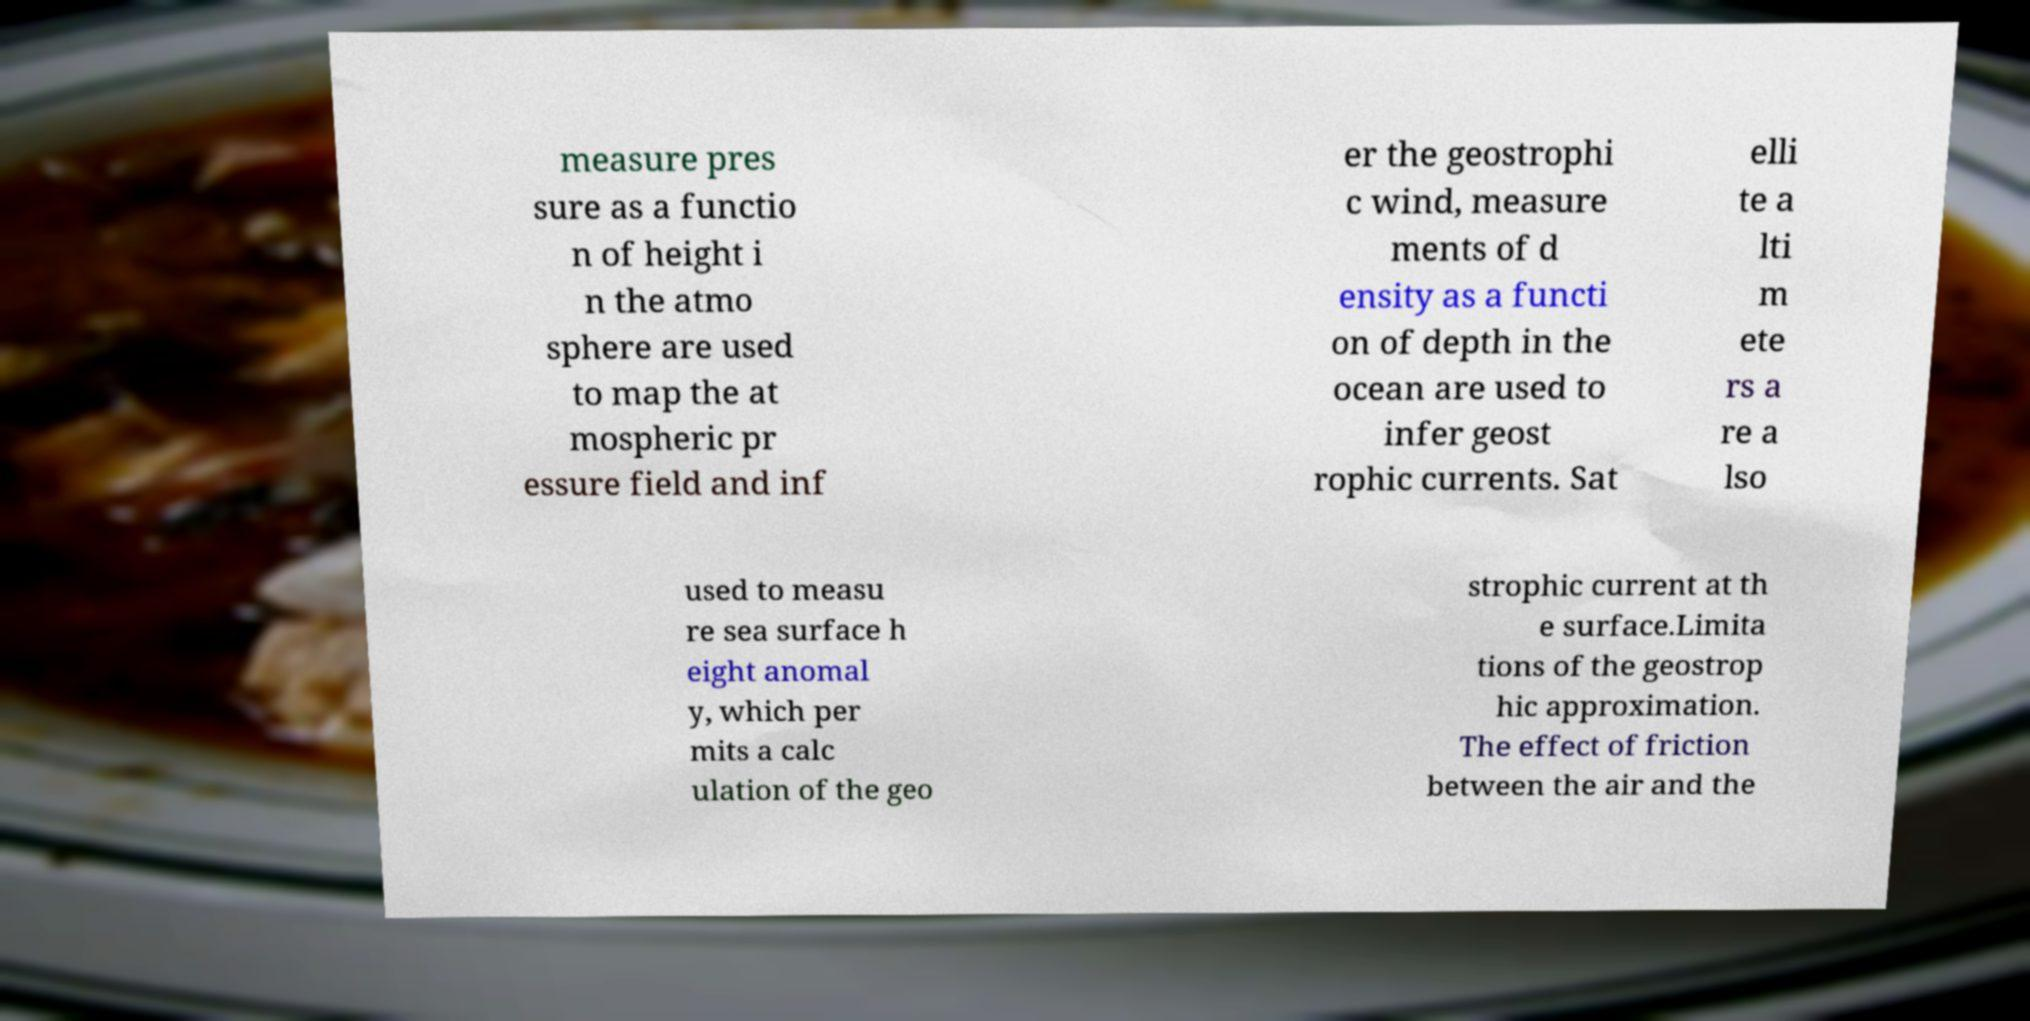Please read and relay the text visible in this image. What does it say? measure pres sure as a functio n of height i n the atmo sphere are used to map the at mospheric pr essure field and inf er the geostrophi c wind, measure ments of d ensity as a functi on of depth in the ocean are used to infer geost rophic currents. Sat elli te a lti m ete rs a re a lso used to measu re sea surface h eight anomal y, which per mits a calc ulation of the geo strophic current at th e surface.Limita tions of the geostrop hic approximation. The effect of friction between the air and the 